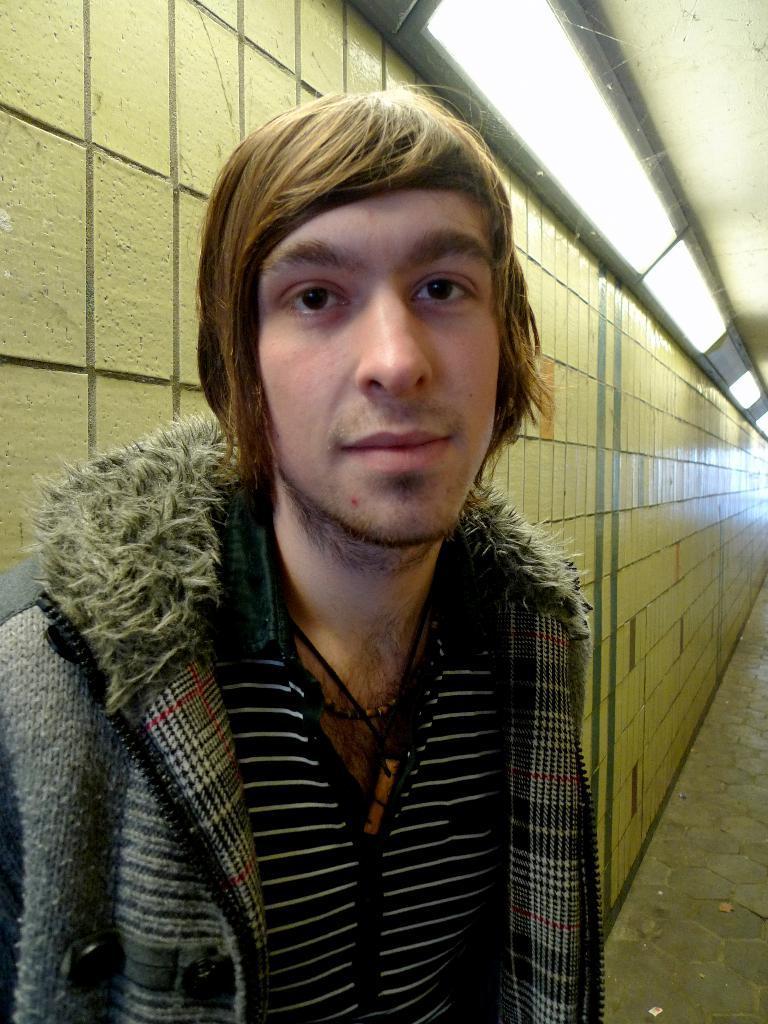Please provide a concise description of this image. In the picture there is a man standing in the foreground and behind the man there is a wall. 